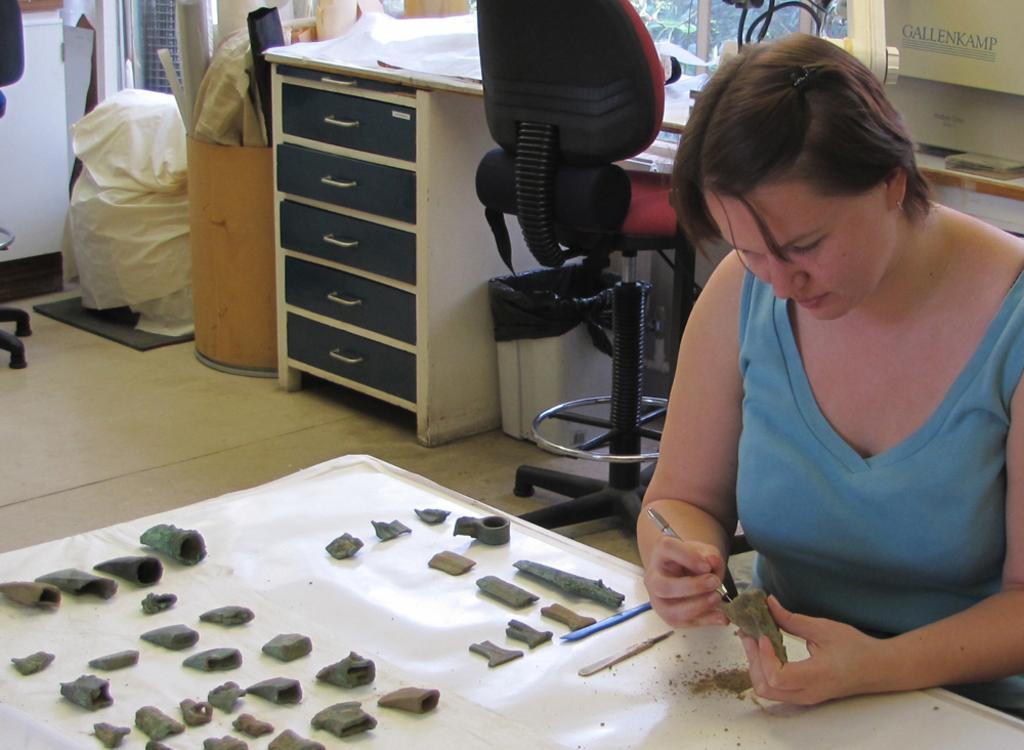Could you give a brief overview of what you see in this image? On the right side of the image there is a woman wearing blue color dress. In front of her there is a table. On the table I can see some instruments. In the background there is a rack, table chair and bag. 